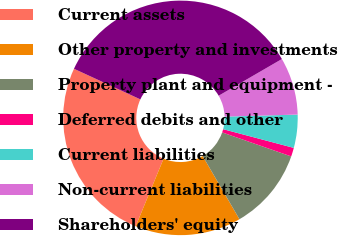Convert chart. <chart><loc_0><loc_0><loc_500><loc_500><pie_chart><fcel>Current assets<fcel>Other property and investments<fcel>Property plant and equipment -<fcel>Deferred debits and other<fcel>Current liabilities<fcel>Non-current liabilities<fcel>Shareholders' equity<nl><fcel>25.64%<fcel>14.63%<fcel>11.28%<fcel>1.21%<fcel>4.57%<fcel>7.92%<fcel>34.76%<nl></chart> 